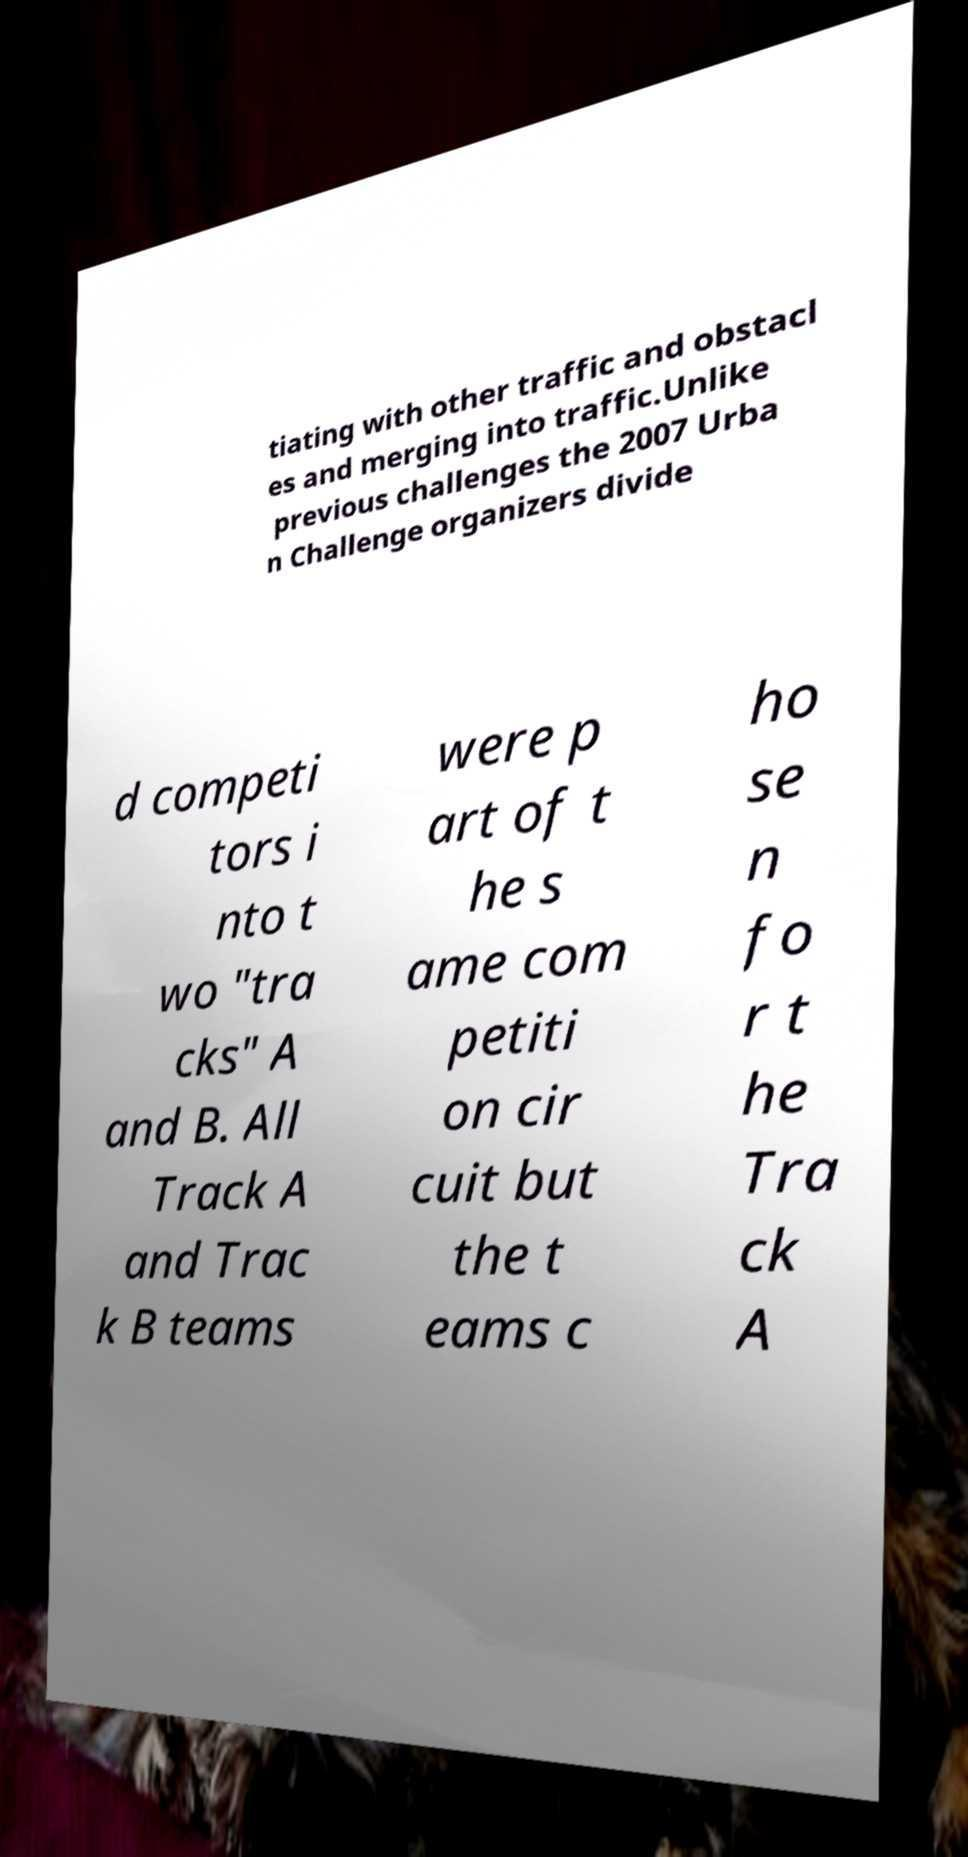Please identify and transcribe the text found in this image. tiating with other traffic and obstacl es and merging into traffic.Unlike previous challenges the 2007 Urba n Challenge organizers divide d competi tors i nto t wo "tra cks" A and B. All Track A and Trac k B teams were p art of t he s ame com petiti on cir cuit but the t eams c ho se n fo r t he Tra ck A 